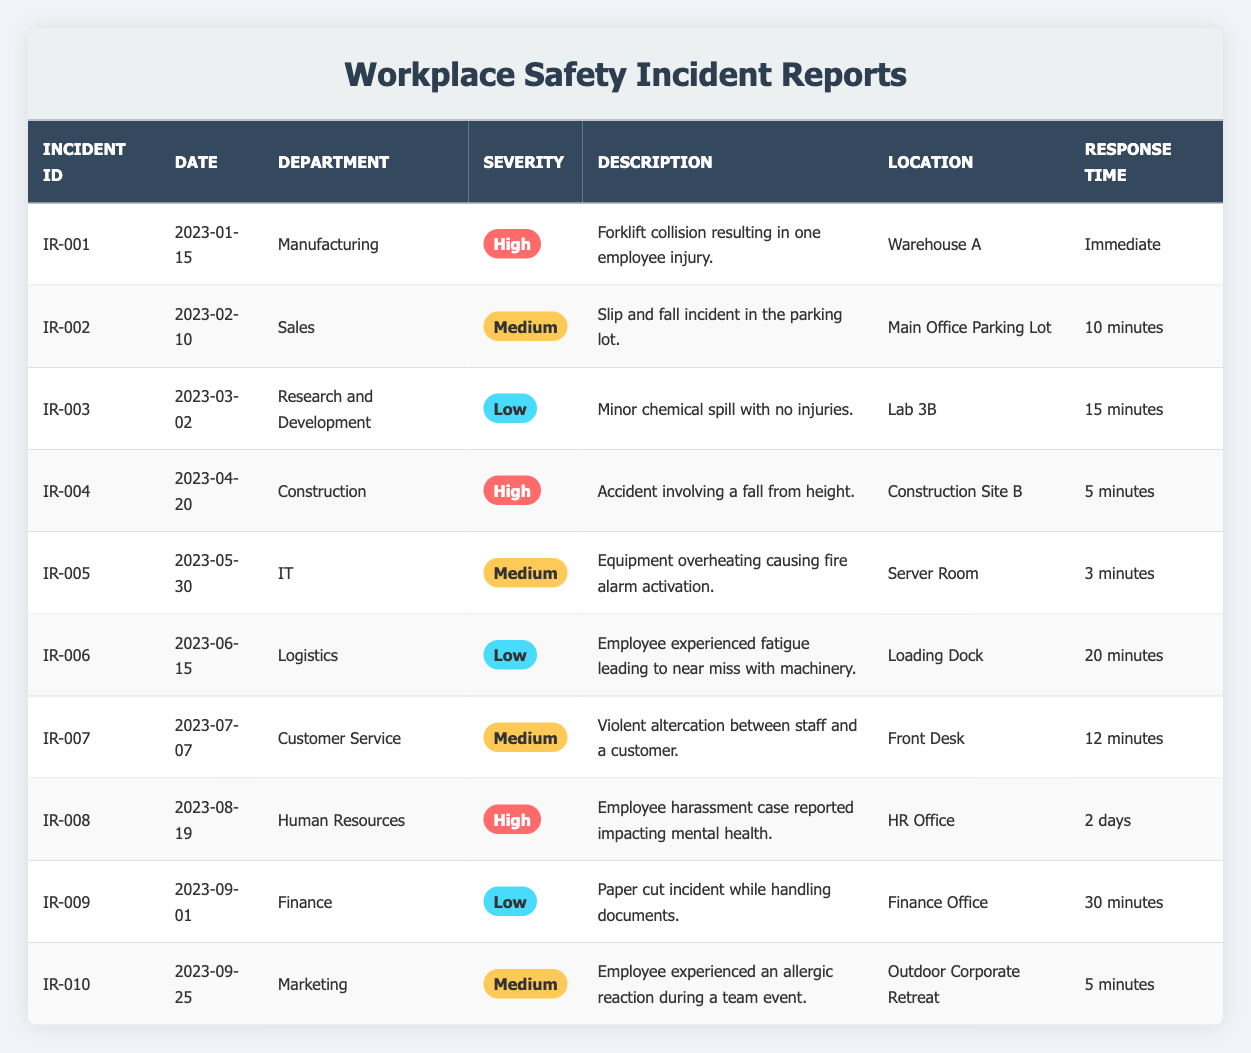What was the highest severity level recorded? The table lists incidents categorized into three severity levels: High, Medium, and Low. The highest level is "High."
Answer: High How many incidents were reported in the Manufacturing department? Referring to the table, there is one incident listed under the Manufacturing department (IR-001).
Answer: 1 What is the response time for the incident in the IT department? The IT department incident (IR-005) shows a response time of 3 minutes in the table.
Answer: 3 minutes Which department had an incident classified as "Medium"? The table shows three incidents with the "Medium" classification: Sales (IR-002), IT (IR-005), and Customer Service (IR-007).
Answer: Sales, IT, Customer Service How many total incidents were categorized as "Low"? The table shows two incidents categorized as "Low": one in Research and Development (IR-003) and one in Logistics (IR-006). Therefore, the total is 2.
Answer: 2 What was the resolution for the incident in the Human Resources department? The HR incident (IR-008) indicates that an investigation was initiated and counseling was offered to affected parties.
Answer: Investigation initiated; counseling offered Did any incidents occur in the month of June? The table indicates one incident in June (IR-006), making the answer true.
Answer: Yes Which incident had the longest response time, and how long was it? The longest response time noted in the table is 2 days for the HR incident (IR-008), making it the longest.
Answer: 2 days What is the average response time for incidents categorized as "High"? The response times for High incidents (IR-001: Immediate, IR-004: 5 minutes, IR-008: 2 days) need to be assessed. Calculating the average: Immediate can be approximated as 0 minutes + 5 minutes + 2880 minutes (2 days) gives 2885 minutes total, divided by 3 gives 961.67 minutes; converting back, that’s approximately 16 hours.
Answer: 16 hours How many total incidents happened in the first quarter of 2023? There were three incidents reported in Q1 2023: January (IR-001), February (IR-002), and March (IR-003), yielding a total of 3.
Answer: 3 Was there an incident with a resolution that involved updating safety training policies? Yes, IR-001 (Manufacturing) reported scheduling forklift safety training and IR-005 (IT) indicated updating training after an equipment issue.
Answer: Yes 